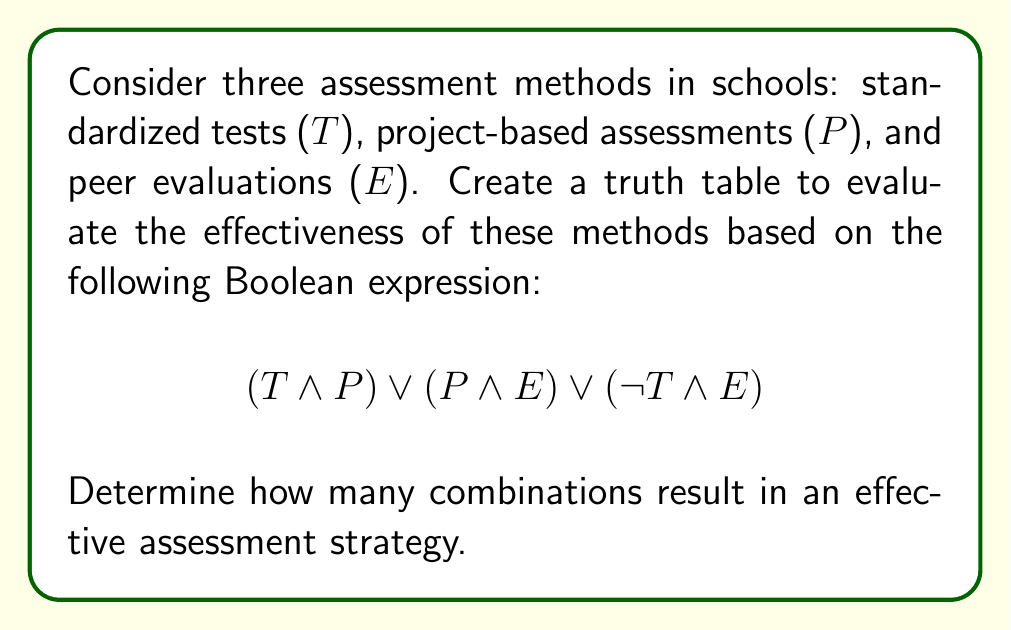Solve this math problem. Let's approach this step-by-step:

1) First, we need to create a truth table with all possible combinations of T, P, and E. There will be $2^3 = 8$ rows in our truth table.

2) We'll evaluate each part of the expression separately:
   a) $(T \land P)$
   b) $(P \land E)$
   c) $(\neg T \land E)$

3) Then, we'll combine these results using OR operations.

4) Here's the complete truth table:

   | T | P | E | $T \land P$ | $P \land E$ | $\neg T \land E$ | Result |
   |---|---|---|-------------|-------------|-------------------|--------|
   | 0 | 0 | 0 |      0      |      0      |         0         |   0    |
   | 0 | 0 | 1 |      0      |      0      |         1         |   1    |
   | 0 | 1 | 0 |      0      |      0      |         0         |   0    |
   | 0 | 1 | 1 |      0      |      1      |         1         |   1    |
   | 1 | 0 | 0 |      0      |      0      |         0         |   0    |
   | 1 | 0 | 1 |      0      |      0      |         0         |   0    |
   | 1 | 1 | 0 |      1      |      0      |         0         |   1    |
   | 1 | 1 | 1 |      1      |      1      |         0         |   1    |

5) Counting the number of 1's in the Result column gives us the number of combinations that result in an effective assessment strategy.

6) There are 4 rows with a Result of 1, corresponding to the following combinations:
   - No standardized tests, no projects, but peer evaluations
   - No standardized tests, projects, and peer evaluations
   - Standardized tests, projects, but no peer evaluations
   - All three methods used together
Answer: 4 